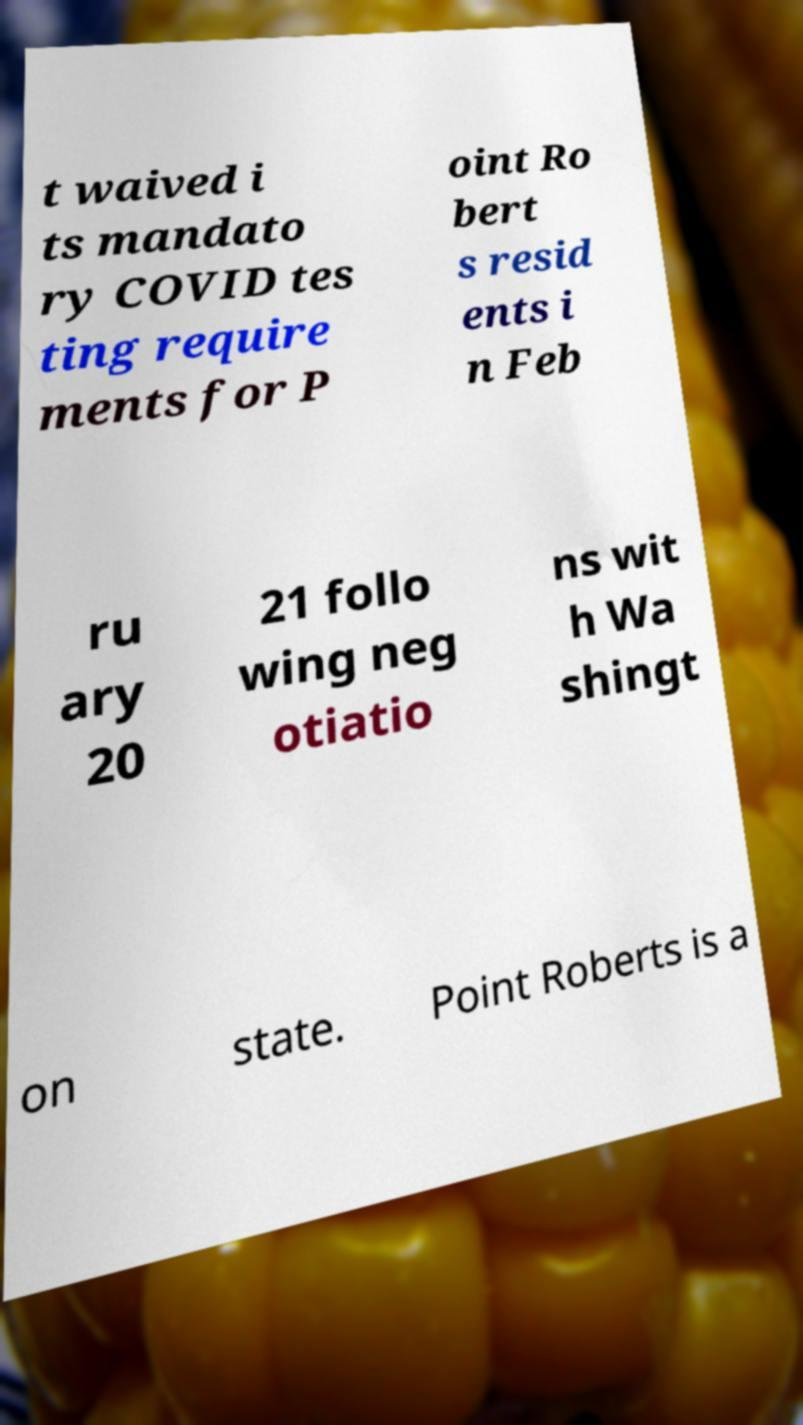What messages or text are displayed in this image? I need them in a readable, typed format. t waived i ts mandato ry COVID tes ting require ments for P oint Ro bert s resid ents i n Feb ru ary 20 21 follo wing neg otiatio ns wit h Wa shingt on state. Point Roberts is a 